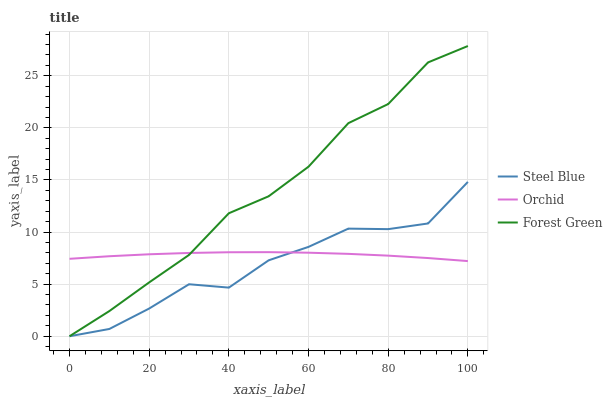Does Steel Blue have the minimum area under the curve?
Answer yes or no. Yes. Does Forest Green have the maximum area under the curve?
Answer yes or no. Yes. Does Orchid have the minimum area under the curve?
Answer yes or no. No. Does Orchid have the maximum area under the curve?
Answer yes or no. No. Is Orchid the smoothest?
Answer yes or no. Yes. Is Steel Blue the roughest?
Answer yes or no. Yes. Is Steel Blue the smoothest?
Answer yes or no. No. Is Orchid the roughest?
Answer yes or no. No. Does Forest Green have the lowest value?
Answer yes or no. Yes. Does Orchid have the lowest value?
Answer yes or no. No. Does Forest Green have the highest value?
Answer yes or no. Yes. Does Steel Blue have the highest value?
Answer yes or no. No. Does Forest Green intersect Orchid?
Answer yes or no. Yes. Is Forest Green less than Orchid?
Answer yes or no. No. Is Forest Green greater than Orchid?
Answer yes or no. No. 